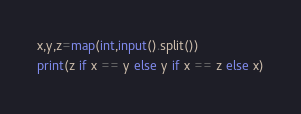Convert code to text. <code><loc_0><loc_0><loc_500><loc_500><_Python_>x,y,z=map(int,input().split())
print(z if x == y else y if x == z else x)</code> 